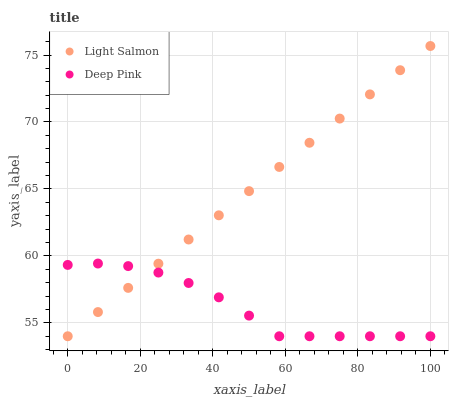Does Deep Pink have the minimum area under the curve?
Answer yes or no. Yes. Does Light Salmon have the maximum area under the curve?
Answer yes or no. Yes. Does Deep Pink have the maximum area under the curve?
Answer yes or no. No. Is Light Salmon the smoothest?
Answer yes or no. Yes. Is Deep Pink the roughest?
Answer yes or no. Yes. Is Deep Pink the smoothest?
Answer yes or no. No. Does Light Salmon have the lowest value?
Answer yes or no. Yes. Does Light Salmon have the highest value?
Answer yes or no. Yes. Does Deep Pink have the highest value?
Answer yes or no. No. Does Light Salmon intersect Deep Pink?
Answer yes or no. Yes. Is Light Salmon less than Deep Pink?
Answer yes or no. No. Is Light Salmon greater than Deep Pink?
Answer yes or no. No. 